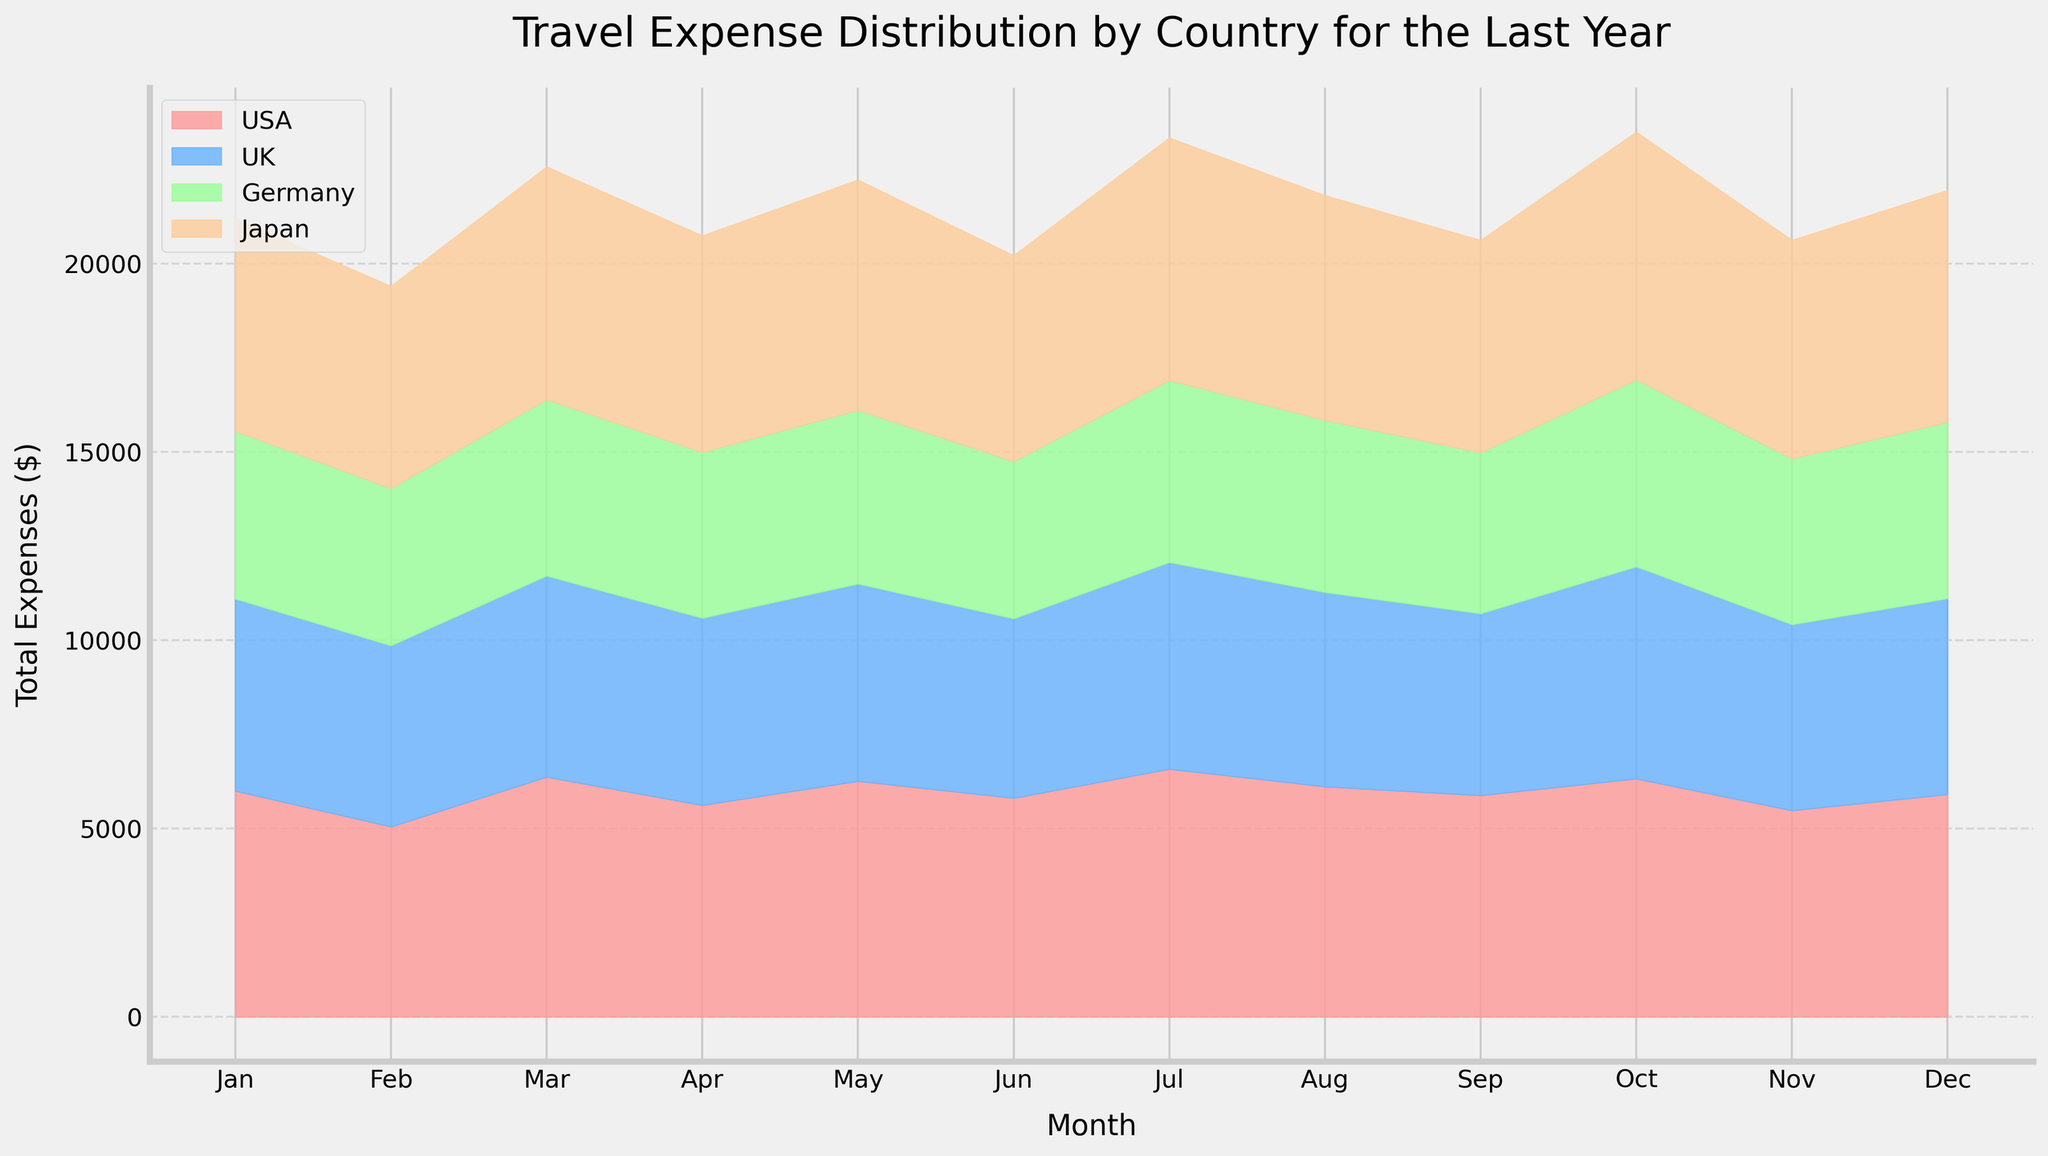What's the title of the chart? The title of the chart is positioned at the top and usually describes the content of the figure. The title here is clear and straightforward.
Answer: Travel Expense Distribution by Country for the Last Year What do the x-axis and y-axis represent? The x-axis represents the months of the year, while the y-axis represents the total expenses in dollars. This is evident from the axis labels.
Answer: Months and Total Expenses ($) Which country appears to have the highest total travel expenses in any given month? By looking at the areas formed by each country, it is noticeable which one has the largest segment above the y-axis.
Answer: USA In which month did Japan have its highest travel expenses? Look at the peak points of the Japan area on the chart. The largest extent of Japan's expenses touches the highest y-value in one specific month.
Answer: October How do the travel expenses in Germany generally compare to those in the USA over the year? Observe the areas filled for Germany and the USA. The USA's area will be consistently higher than Germany's indicating higher expenses.
Answer: The USA has higher travel expenses than Germany consistently What is the total expense for the month of December across all countries? To determine this, one needs to sum up the expenses for all countries in December based on the stack heights in the area chart.
Answer: (USA: 1500+2950+990+470) + (UK: 1400+2500+900+400) + (Germany: 1200+2300+820+360) + (Japan: 1650+3000+1050+460) = 31,720 Which months show the lowest total expenses across all countries? Identify the months where the total area under the curve is at its lowest point.
Answer: February Do the travel expenses in the UK exceed those in Germany in any month? Compare the areas specifically for the UK and Germany month by month. Look for any month where the UK's area is above Germany's.
Answer: Yes, in October and November What is the general trend for Japan's travel expenses over the year? Observe the shape of the area corresponding to Japan throughout the months, noting increases or decreases.
Answer: Generally increasing with peaks in March and October Is there any month where all countries have equal expenses? Examine the chart to see if any month has equal heights for all stacked areas, which would indicate equal expenses.
Answer: No 